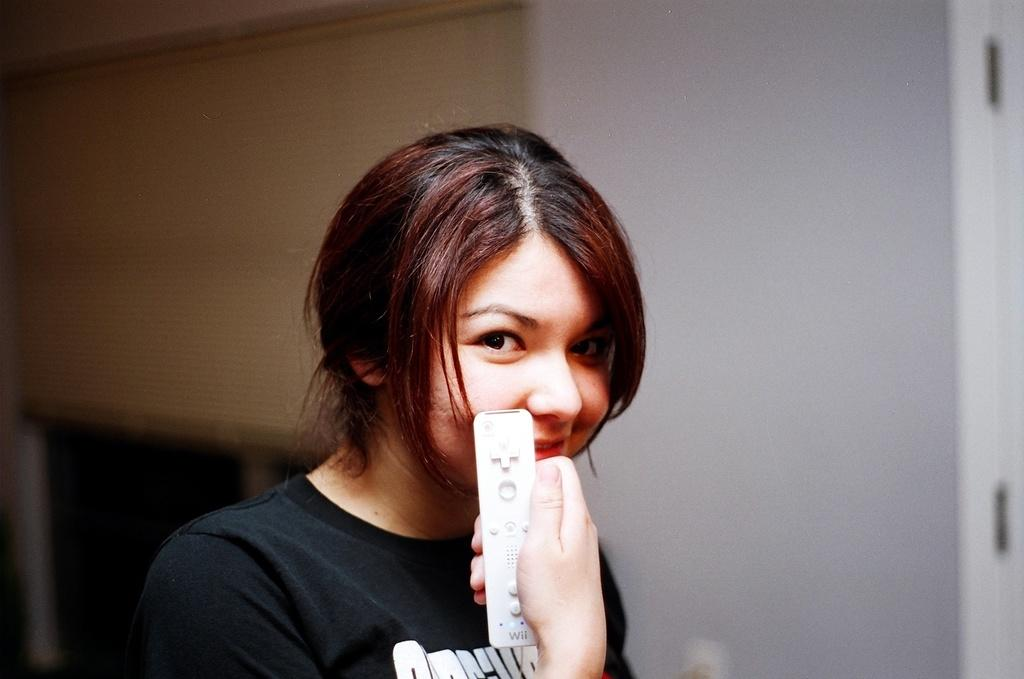Who is the main subject in the image? There is a woman in the image. What is the woman doing in the image? The woman is smiling. What object is the woman holding in the image? The woman is holding a remote. What can be seen in the background of the image? There is a wall, a door, and a window in the background of the image. What level of connection does the woman have with her mother in the image? There is no information about the woman's mother or their relationship in the image. 